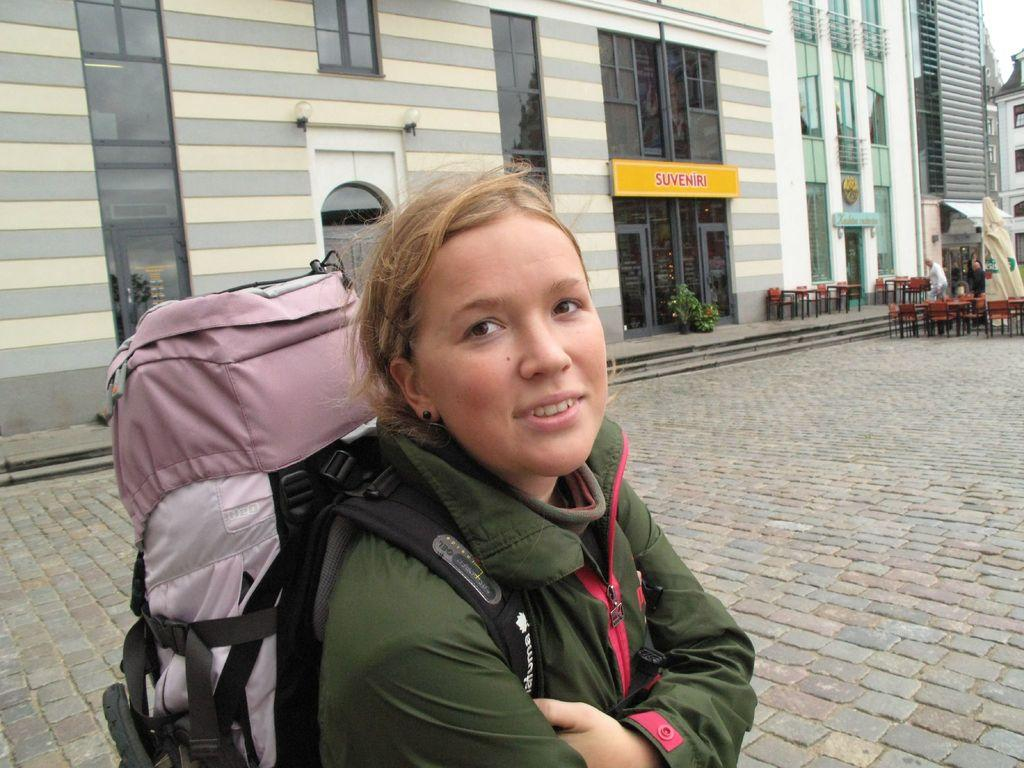<image>
Render a clear and concise summary of the photo. the word suveniri is on the building behind the girl 